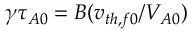<formula> <loc_0><loc_0><loc_500><loc_500>\gamma \tau _ { A 0 } = B ( v _ { t h , f 0 } / V _ { A 0 } )</formula> 